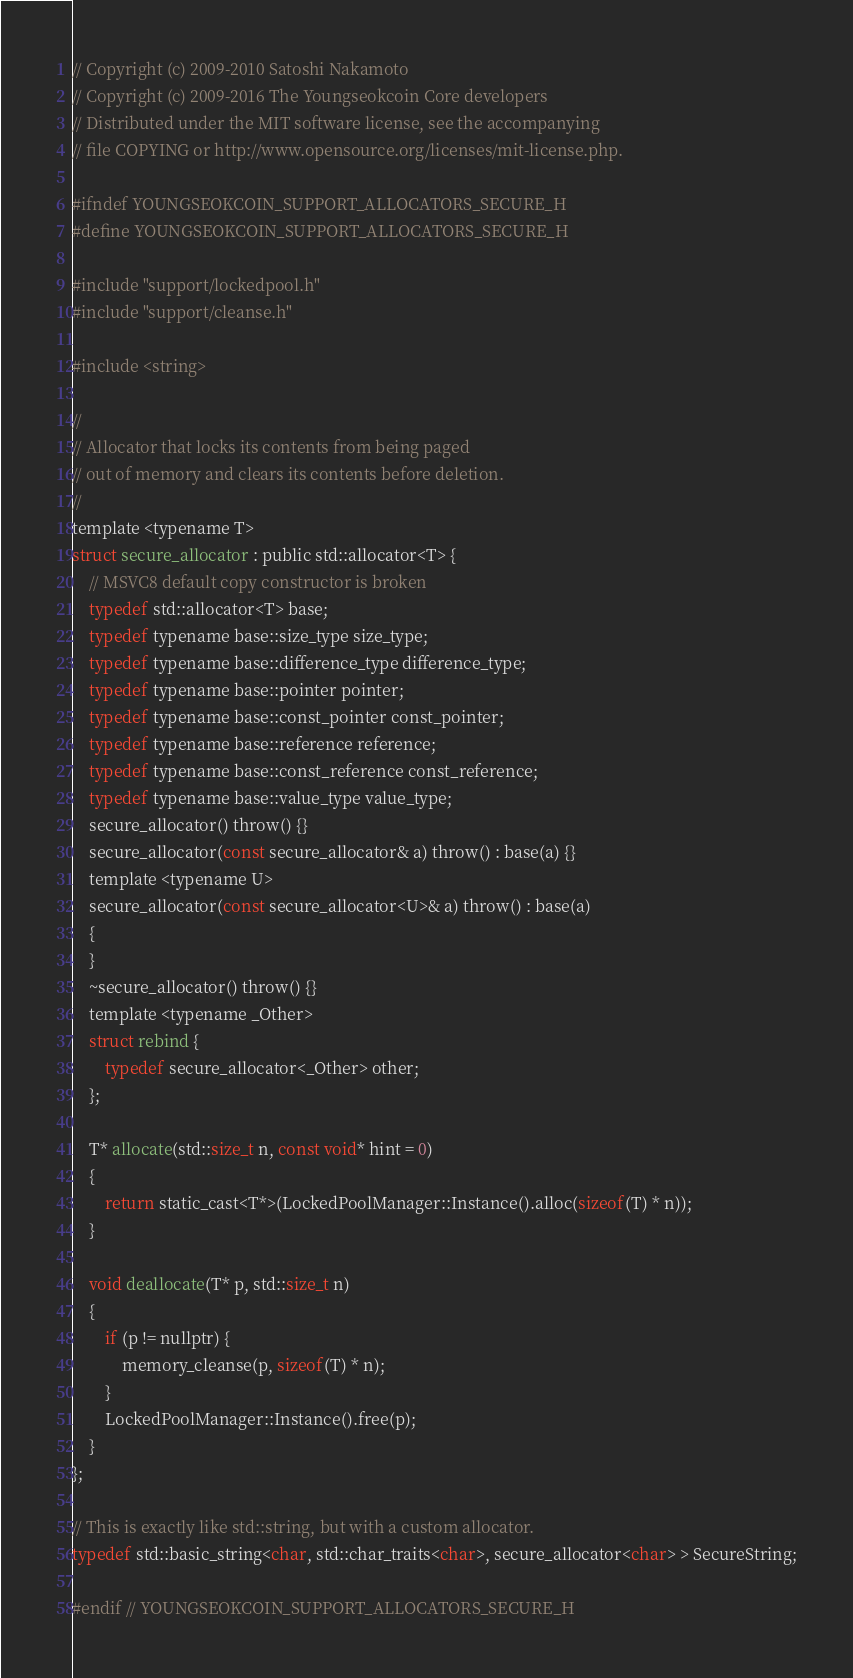<code> <loc_0><loc_0><loc_500><loc_500><_C_>// Copyright (c) 2009-2010 Satoshi Nakamoto
// Copyright (c) 2009-2016 The Youngseokcoin Core developers
// Distributed under the MIT software license, see the accompanying
// file COPYING or http://www.opensource.org/licenses/mit-license.php.

#ifndef YOUNGSEOKCOIN_SUPPORT_ALLOCATORS_SECURE_H
#define YOUNGSEOKCOIN_SUPPORT_ALLOCATORS_SECURE_H

#include "support/lockedpool.h"
#include "support/cleanse.h"

#include <string>

//
// Allocator that locks its contents from being paged
// out of memory and clears its contents before deletion.
//
template <typename T>
struct secure_allocator : public std::allocator<T> {
    // MSVC8 default copy constructor is broken
    typedef std::allocator<T> base;
    typedef typename base::size_type size_type;
    typedef typename base::difference_type difference_type;
    typedef typename base::pointer pointer;
    typedef typename base::const_pointer const_pointer;
    typedef typename base::reference reference;
    typedef typename base::const_reference const_reference;
    typedef typename base::value_type value_type;
    secure_allocator() throw() {}
    secure_allocator(const secure_allocator& a) throw() : base(a) {}
    template <typename U>
    secure_allocator(const secure_allocator<U>& a) throw() : base(a)
    {
    }
    ~secure_allocator() throw() {}
    template <typename _Other>
    struct rebind {
        typedef secure_allocator<_Other> other;
    };

    T* allocate(std::size_t n, const void* hint = 0)
    {
        return static_cast<T*>(LockedPoolManager::Instance().alloc(sizeof(T) * n));
    }

    void deallocate(T* p, std::size_t n)
    {
        if (p != nullptr) {
            memory_cleanse(p, sizeof(T) * n);
        }
        LockedPoolManager::Instance().free(p);
    }
};

// This is exactly like std::string, but with a custom allocator.
typedef std::basic_string<char, std::char_traits<char>, secure_allocator<char> > SecureString;

#endif // YOUNGSEOKCOIN_SUPPORT_ALLOCATORS_SECURE_H
</code> 